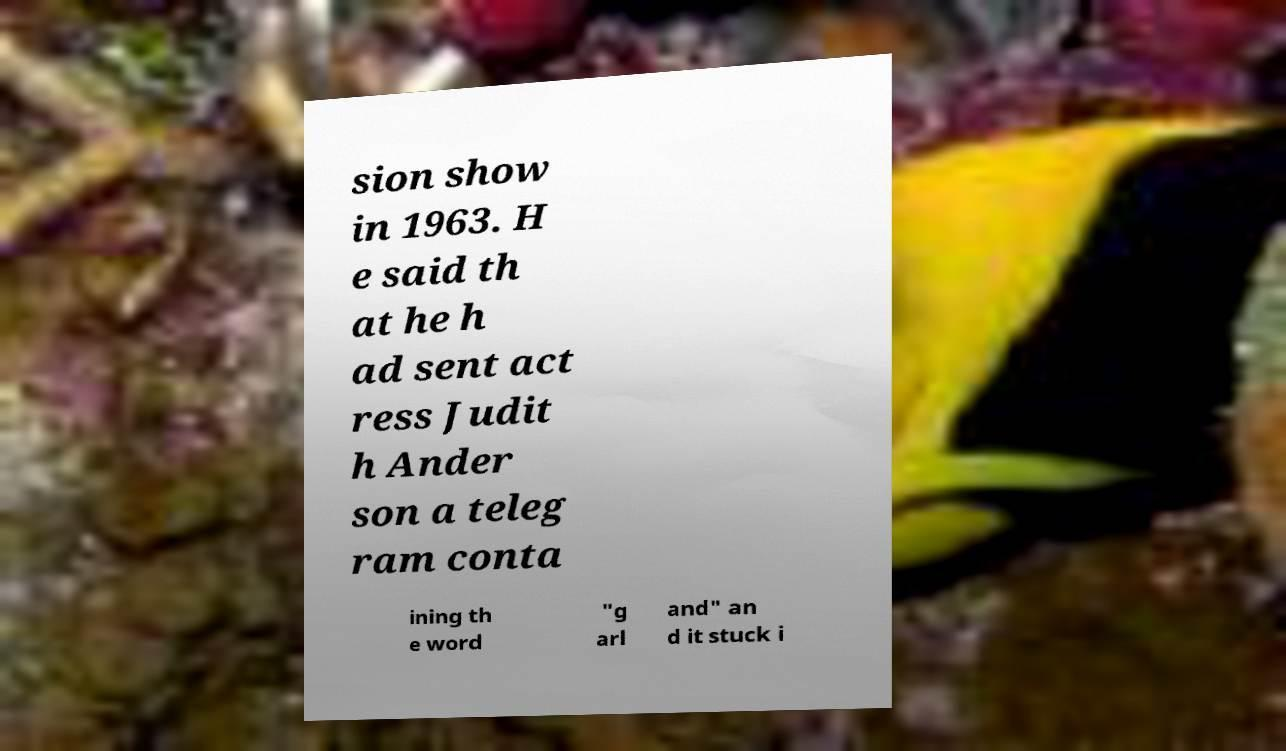Please identify and transcribe the text found in this image. sion show in 1963. H e said th at he h ad sent act ress Judit h Ander son a teleg ram conta ining th e word "g arl and" an d it stuck i 